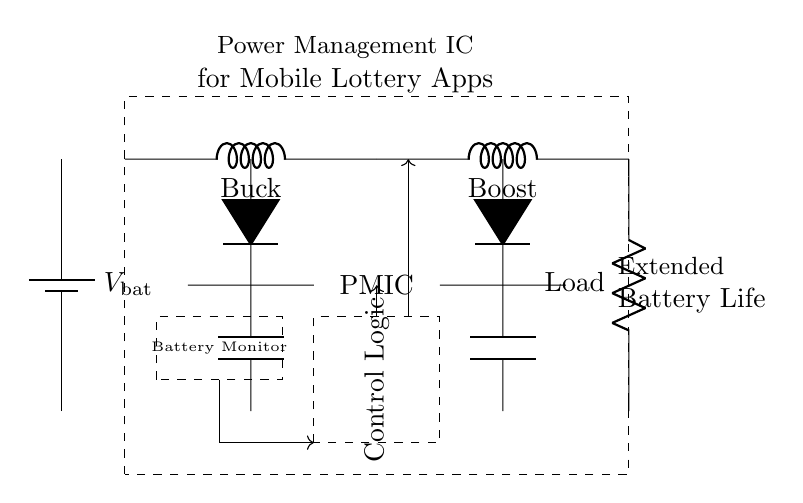What is the main function of the PMIC in this circuit? The Power Management Integrated Circuit (PMIC) manages power distribution to extend battery life in mobile devices. It includes a buck converter for stepping down voltage and a boost converter for stepping up voltage.
Answer: Power management What components are involved in voltage conversion? The circuit includes a buck converter, which reduces the voltage, and a boost converter, which increases the voltage, to manage different load requirements.
Answer: Buck and boost converters How many main sections does the PMIC have? There are three main sections in the PMIC: the buck converter, the boost converter, and the control logic that oversees their operation.
Answer: Three What is the purpose of the battery monitor? The battery monitor tracks the battery's state, ensuring the PMIC maintains optimal performance and prevents overdischarging by monitoring voltage levels.
Answer: Battery monitoring What does the dashed box signify in the diagram? The dashed boxes denote functional blocks within the circuit—one for the PMIC overall and another for the control logic, indicating specific components and their roles.
Answer: Functional blocks What role does the load play in this circuit? The load represents the component(s) that consume power from the PMIC, highlighting how power is distributed to mobile apps running on the device.
Answer: Power consumption 